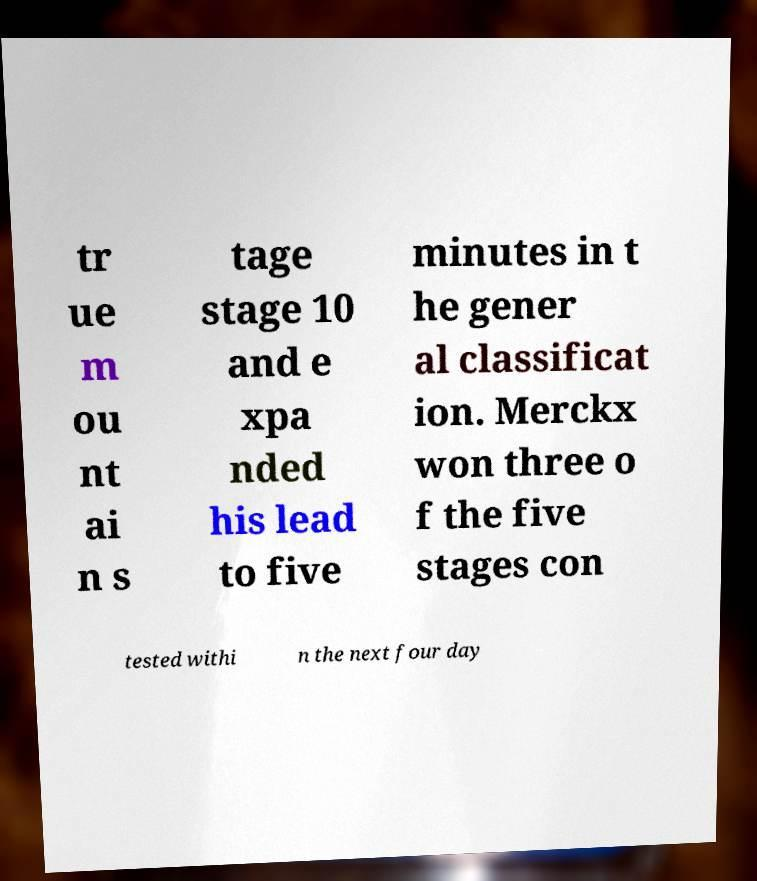What messages or text are displayed in this image? I need them in a readable, typed format. tr ue m ou nt ai n s tage stage 10 and e xpa nded his lead to five minutes in t he gener al classificat ion. Merckx won three o f the five stages con tested withi n the next four day 